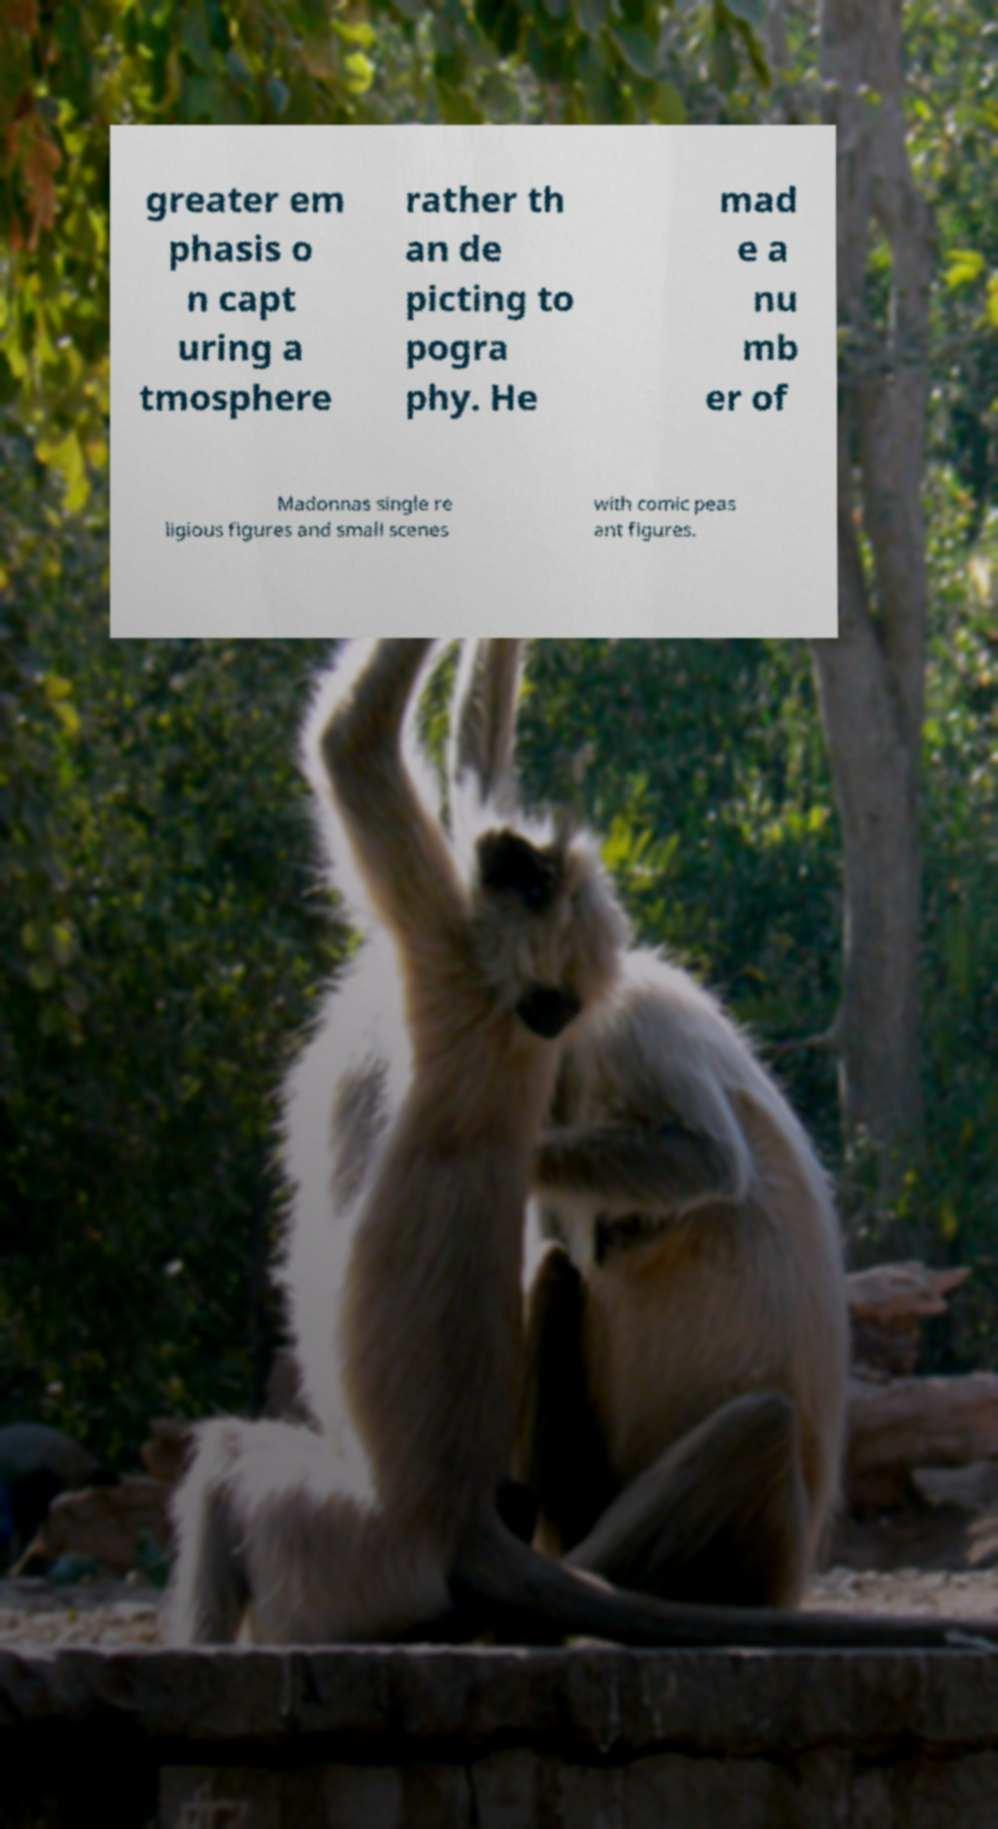I need the written content from this picture converted into text. Can you do that? greater em phasis o n capt uring a tmosphere rather th an de picting to pogra phy. He mad e a nu mb er of Madonnas single re ligious figures and small scenes with comic peas ant figures. 